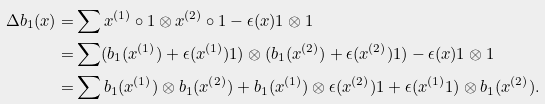<formula> <loc_0><loc_0><loc_500><loc_500>\Delta b _ { 1 } ( x ) = & \sum x ^ { ( 1 ) } \circ 1 \otimes x ^ { ( 2 ) } \circ 1 - \epsilon ( x ) 1 \otimes 1 \\ = & \sum ( b _ { 1 } ( x ^ { ( 1 ) } ) + \epsilon ( x ^ { ( 1 ) } ) 1 ) \otimes ( b _ { 1 } ( x ^ { ( 2 ) } ) + \epsilon ( x ^ { ( 2 ) } ) 1 ) - \epsilon ( x ) 1 \otimes 1 \\ = & \sum b _ { 1 } ( x ^ { ( 1 ) } ) \otimes b _ { 1 } ( x ^ { ( 2 ) } ) + b _ { 1 } ( x ^ { ( 1 ) } ) \otimes \epsilon ( x ^ { ( 2 ) } ) 1 + \epsilon ( x ^ { ( 1 ) } 1 ) \otimes b _ { 1 } ( x ^ { ( 2 ) } ) .</formula> 